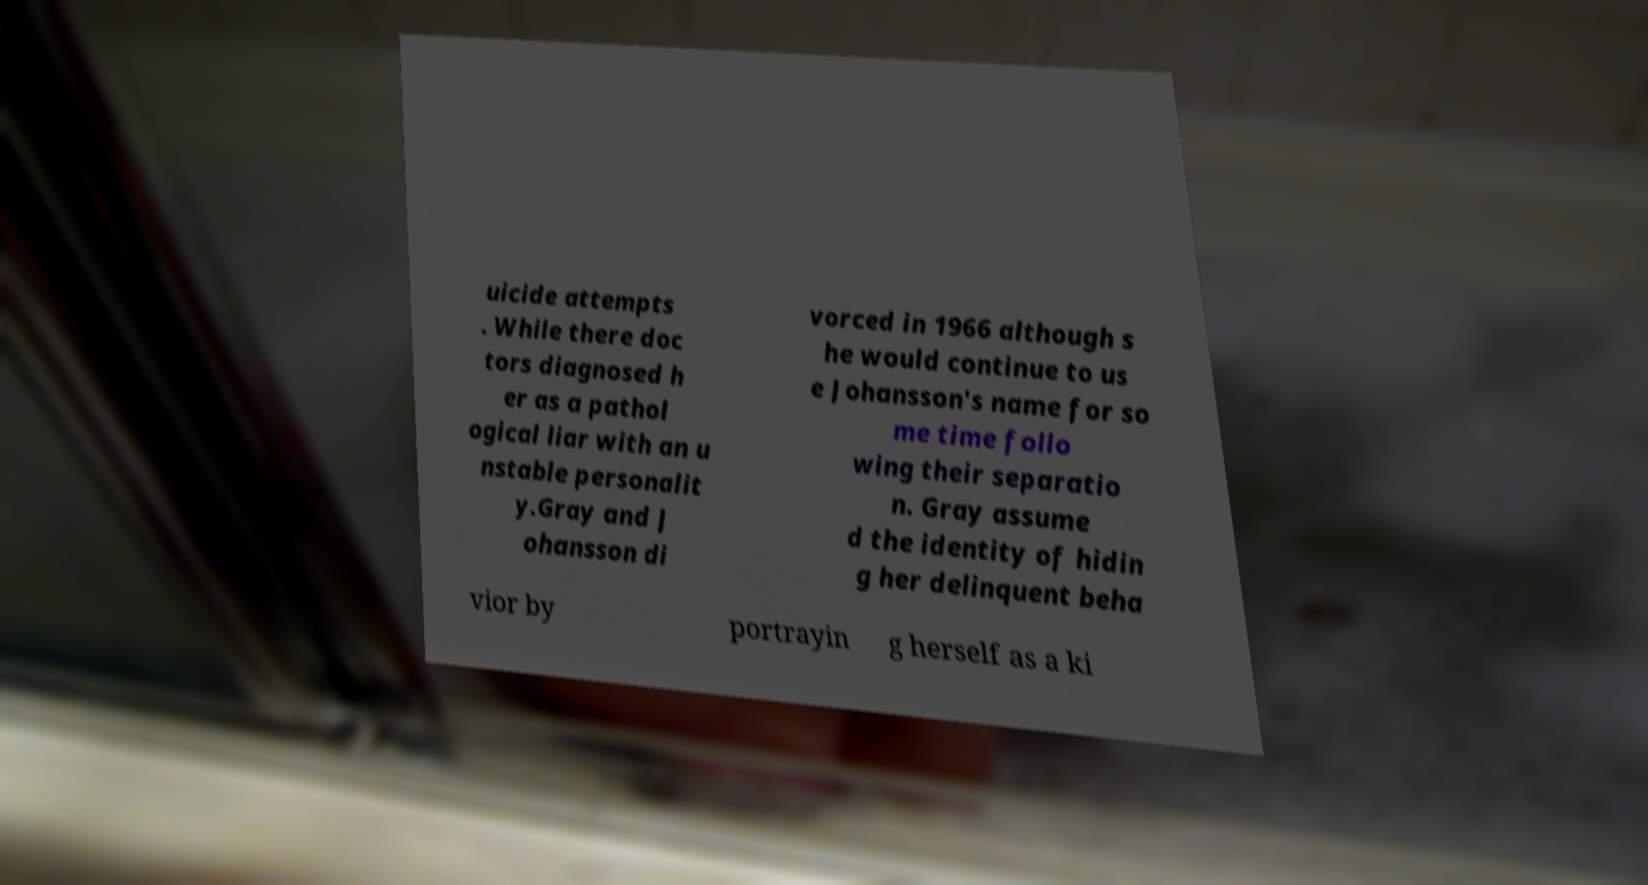Can you read and provide the text displayed in the image?This photo seems to have some interesting text. Can you extract and type it out for me? uicide attempts . While there doc tors diagnosed h er as a pathol ogical liar with an u nstable personalit y.Gray and J ohansson di vorced in 1966 although s he would continue to us e Johansson's name for so me time follo wing their separatio n. Gray assume d the identity of hidin g her delinquent beha vior by portrayin g herself as a ki 